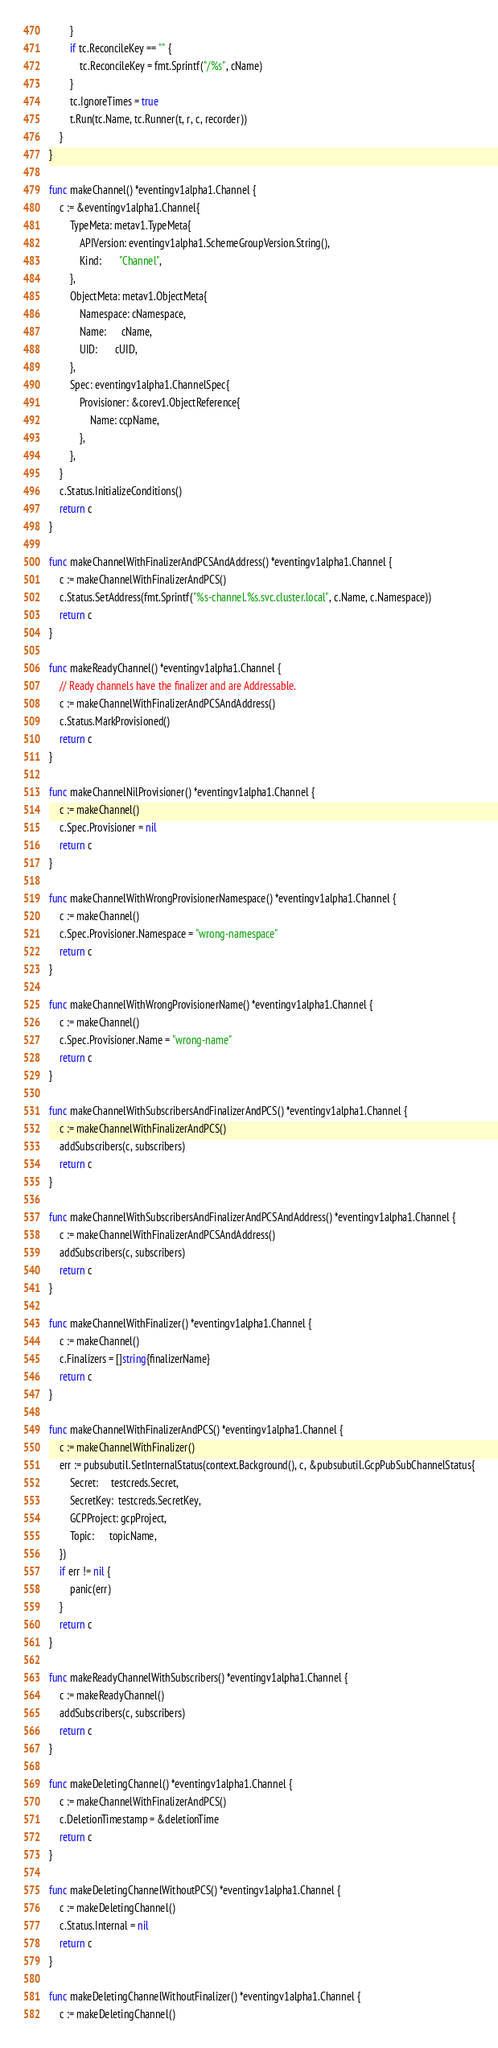Convert code to text. <code><loc_0><loc_0><loc_500><loc_500><_Go_>		}
		if tc.ReconcileKey == "" {
			tc.ReconcileKey = fmt.Sprintf("/%s", cName)
		}
		tc.IgnoreTimes = true
		t.Run(tc.Name, tc.Runner(t, r, c, recorder))
	}
}

func makeChannel() *eventingv1alpha1.Channel {
	c := &eventingv1alpha1.Channel{
		TypeMeta: metav1.TypeMeta{
			APIVersion: eventingv1alpha1.SchemeGroupVersion.String(),
			Kind:       "Channel",
		},
		ObjectMeta: metav1.ObjectMeta{
			Namespace: cNamespace,
			Name:      cName,
			UID:       cUID,
		},
		Spec: eventingv1alpha1.ChannelSpec{
			Provisioner: &corev1.ObjectReference{
				Name: ccpName,
			},
		},
	}
	c.Status.InitializeConditions()
	return c
}

func makeChannelWithFinalizerAndPCSAndAddress() *eventingv1alpha1.Channel {
	c := makeChannelWithFinalizerAndPCS()
	c.Status.SetAddress(fmt.Sprintf("%s-channel.%s.svc.cluster.local", c.Name, c.Namespace))
	return c
}

func makeReadyChannel() *eventingv1alpha1.Channel {
	// Ready channels have the finalizer and are Addressable.
	c := makeChannelWithFinalizerAndPCSAndAddress()
	c.Status.MarkProvisioned()
	return c
}

func makeChannelNilProvisioner() *eventingv1alpha1.Channel {
	c := makeChannel()
	c.Spec.Provisioner = nil
	return c
}

func makeChannelWithWrongProvisionerNamespace() *eventingv1alpha1.Channel {
	c := makeChannel()
	c.Spec.Provisioner.Namespace = "wrong-namespace"
	return c
}

func makeChannelWithWrongProvisionerName() *eventingv1alpha1.Channel {
	c := makeChannel()
	c.Spec.Provisioner.Name = "wrong-name"
	return c
}

func makeChannelWithSubscribersAndFinalizerAndPCS() *eventingv1alpha1.Channel {
	c := makeChannelWithFinalizerAndPCS()
	addSubscribers(c, subscribers)
	return c
}

func makeChannelWithSubscribersAndFinalizerAndPCSAndAddress() *eventingv1alpha1.Channel {
	c := makeChannelWithFinalizerAndPCSAndAddress()
	addSubscribers(c, subscribers)
	return c
}

func makeChannelWithFinalizer() *eventingv1alpha1.Channel {
	c := makeChannel()
	c.Finalizers = []string{finalizerName}
	return c
}

func makeChannelWithFinalizerAndPCS() *eventingv1alpha1.Channel {
	c := makeChannelWithFinalizer()
	err := pubsubutil.SetInternalStatus(context.Background(), c, &pubsubutil.GcpPubSubChannelStatus{
		Secret:     testcreds.Secret,
		SecretKey:  testcreds.SecretKey,
		GCPProject: gcpProject,
		Topic:      topicName,
	})
	if err != nil {
		panic(err)
	}
	return c
}

func makeReadyChannelWithSubscribers() *eventingv1alpha1.Channel {
	c := makeReadyChannel()
	addSubscribers(c, subscribers)
	return c
}

func makeDeletingChannel() *eventingv1alpha1.Channel {
	c := makeChannelWithFinalizerAndPCS()
	c.DeletionTimestamp = &deletionTime
	return c
}

func makeDeletingChannelWithoutPCS() *eventingv1alpha1.Channel {
	c := makeDeletingChannel()
	c.Status.Internal = nil
	return c
}

func makeDeletingChannelWithoutFinalizer() *eventingv1alpha1.Channel {
	c := makeDeletingChannel()</code> 